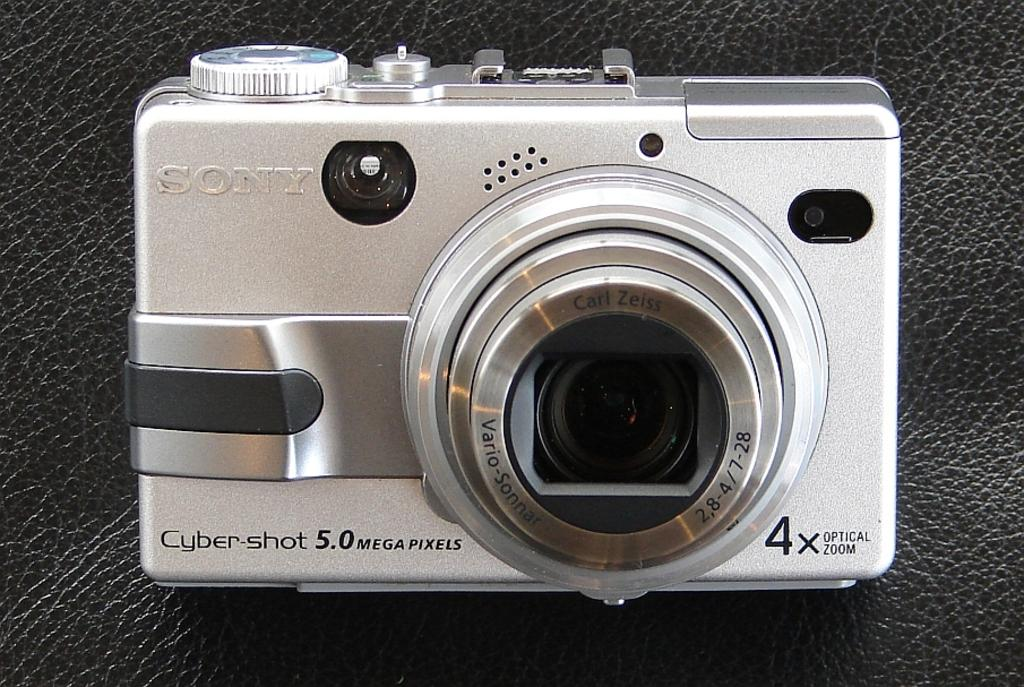What object is the main subject of the image? There is a camera in the image. Where is the camera located? The camera is on a table. Is there any text or label on the camera? Yes, the word "Song" is written on the camera. Can you see any person eating jam on the road in the image? There is no person or jam on the road in the image; it only features a camera on a table with the word "Song" written on it. 